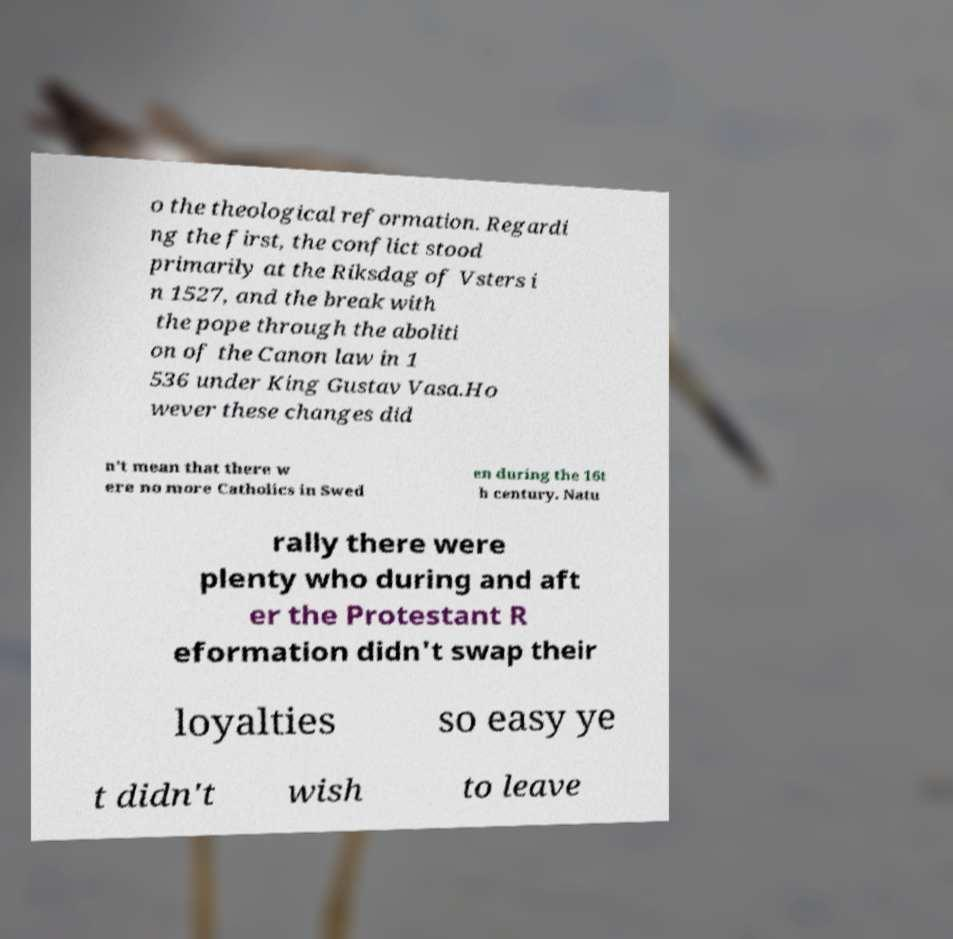Can you accurately transcribe the text from the provided image for me? o the theological reformation. Regardi ng the first, the conflict stood primarily at the Riksdag of Vsters i n 1527, and the break with the pope through the aboliti on of the Canon law in 1 536 under King Gustav Vasa.Ho wever these changes did n't mean that there w ere no more Catholics in Swed en during the 16t h century. Natu rally there were plenty who during and aft er the Protestant R eformation didn't swap their loyalties so easy ye t didn't wish to leave 